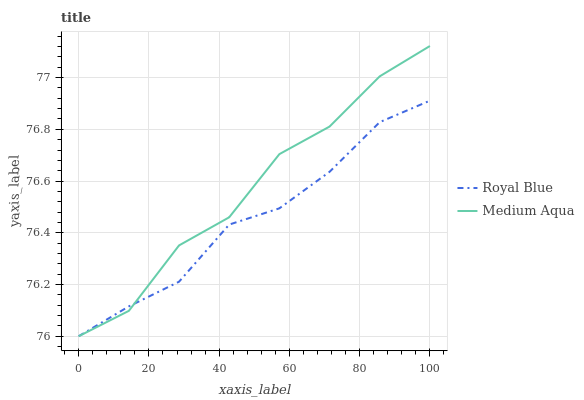Does Royal Blue have the minimum area under the curve?
Answer yes or no. Yes. Does Medium Aqua have the maximum area under the curve?
Answer yes or no. Yes. Does Medium Aqua have the minimum area under the curve?
Answer yes or no. No. Is Royal Blue the smoothest?
Answer yes or no. Yes. Is Medium Aqua the roughest?
Answer yes or no. Yes. Is Medium Aqua the smoothest?
Answer yes or no. No. Does Medium Aqua have the highest value?
Answer yes or no. Yes. 